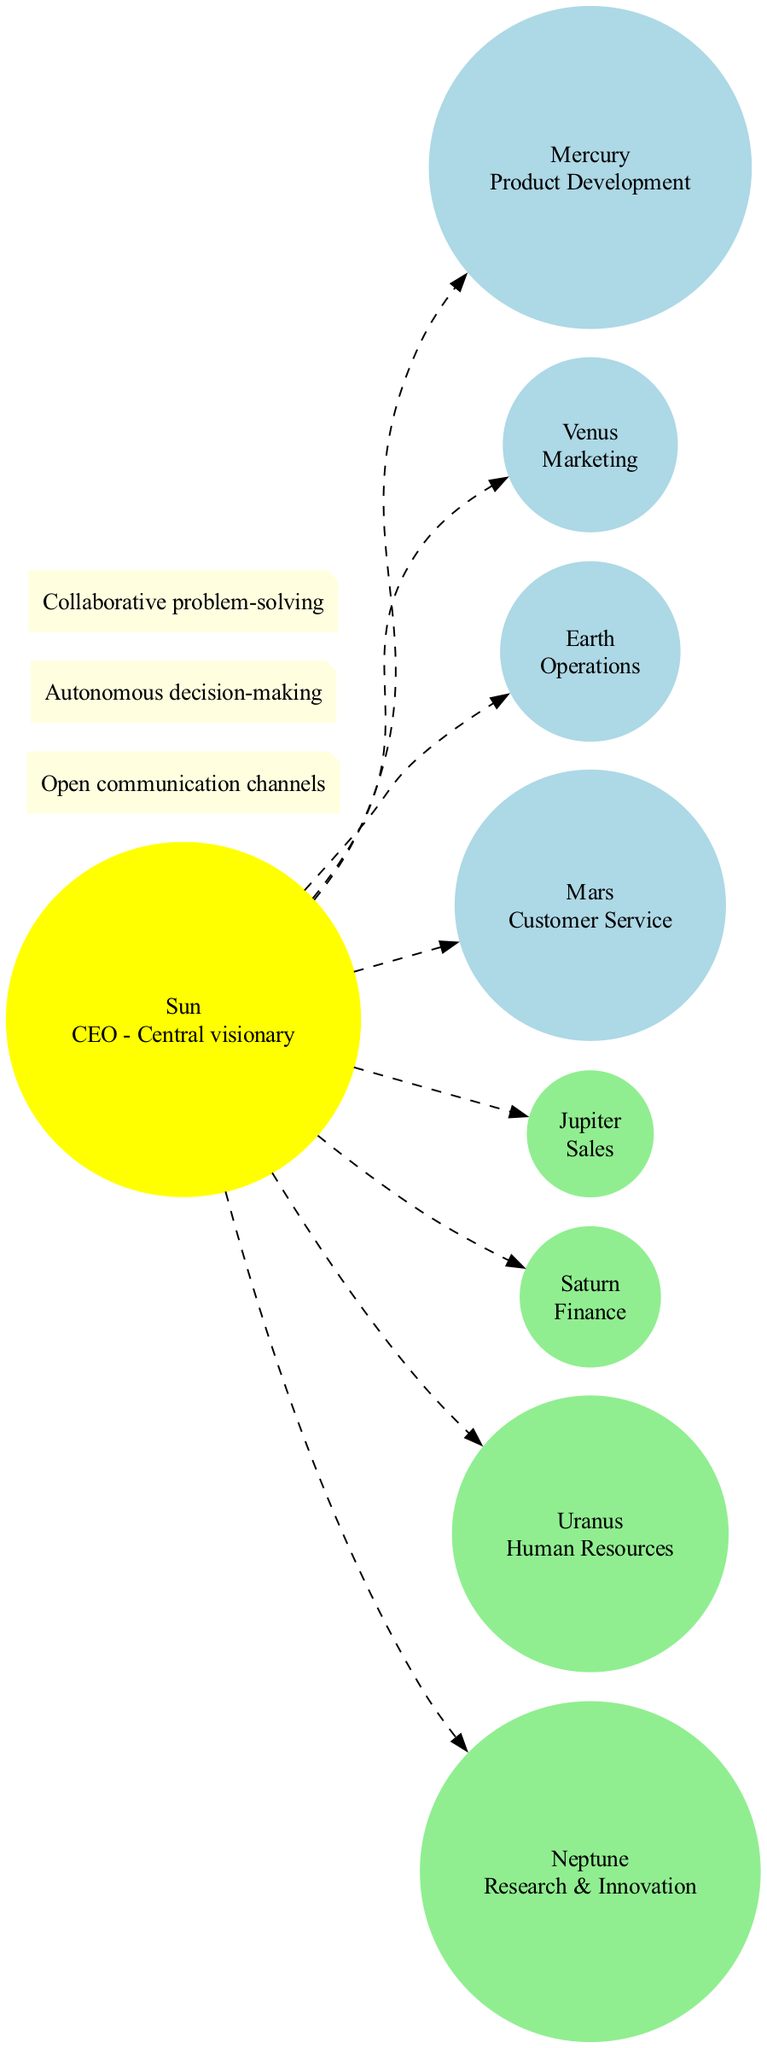What is the name of the central body in the diagram? The central body, referred to as the "Sun," serves as the CEO in the diagram. It is the most prominent focus point within the structure.
Answer: Sun How many inner planets are represented in the diagram? The inner planets include Mercury, Venus, Earth, and Mars. Counting these gives a total of four inner planets.
Answer: 4 What is the description of Jupiter in the diagram? Jupiter is labeled as "Sales" in the diagram, indicating its role within the organizational structure.
Answer: Sales Which connection describes the role of decision-making in this organization? The connection labeled "Autonomous decision-making" captures the essence of decentralized decision-making within the organization.
Answer: Autonomous decision-making What describes the connection between the Sun and the inner planets? The edges connecting the Sun to each inner planet are represented as dashed lines, signifying open communication channels in the organizational structure.
Answer: Open communication channels What is the function of Earth in this flat organization? Earth is designated as "Operations," which signifies its role in managing the day-to-day functioning of the organization.
Answer: Operations How many outer planets are mentioned in the diagram? The outer planets listed in the diagram are Jupiter, Saturn, Uranus, and Neptune. There are four outer planets in total.
Answer: 4 Which planet corresponds to Human Resources? Uranus is identified in the diagram as the planet representing "Human Resources."
Answer: Uranus What type of communication does the diagram emphasize among team members? The diagram emphasizes "Collaborative problem-solving," which showcases the preferred method of interaction among team members in the organization.
Answer: Collaborative problem-solving 